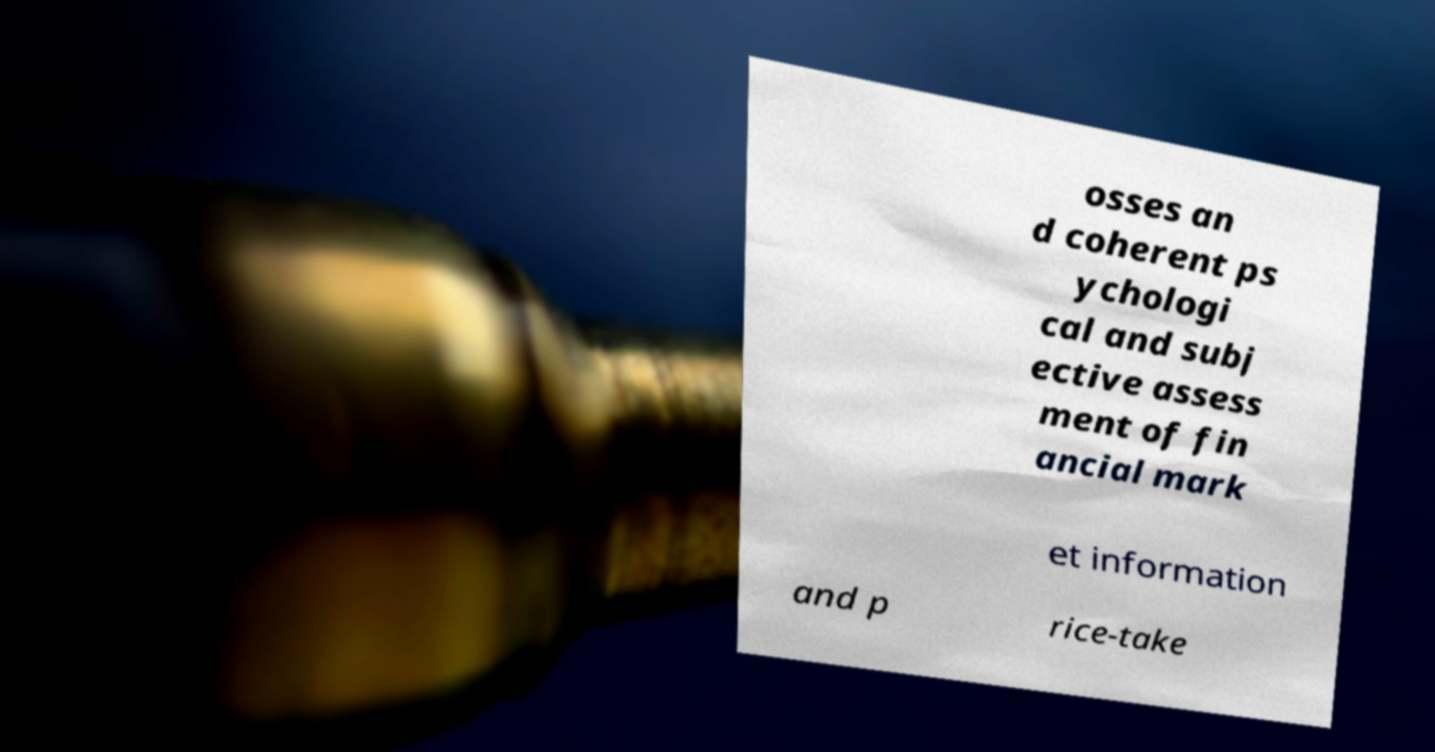Could you assist in decoding the text presented in this image and type it out clearly? osses an d coherent ps ychologi cal and subj ective assess ment of fin ancial mark et information and p rice-take 